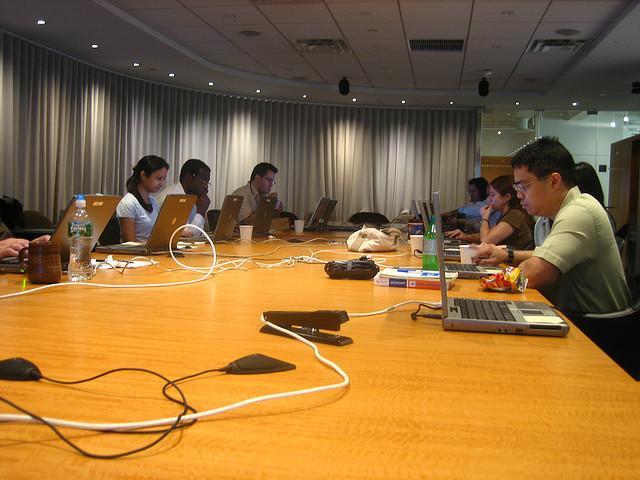Where are the people in? conference room 